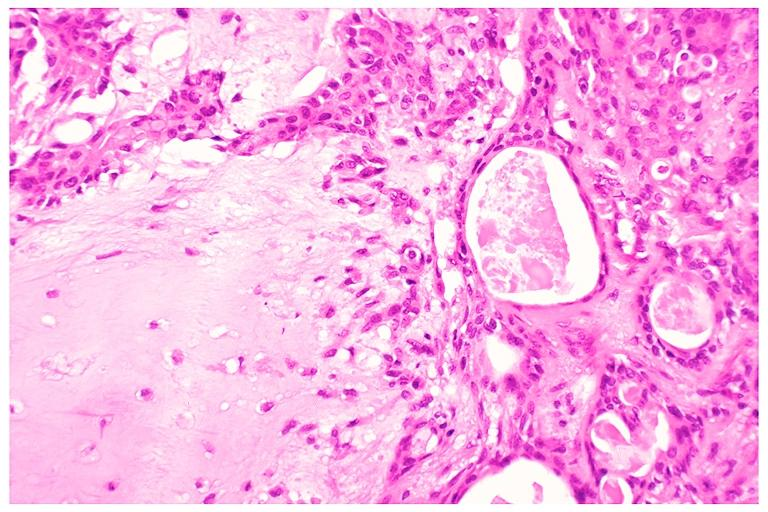what is present?
Answer the question using a single word or phrase. Oral 